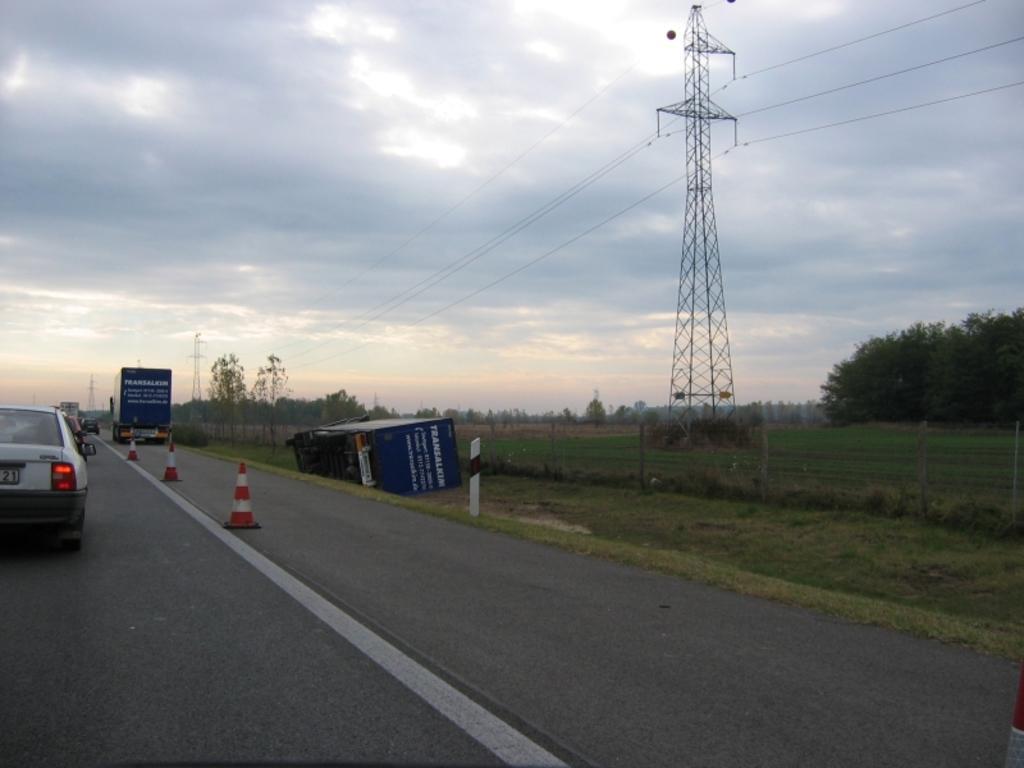In one or two sentences, can you explain what this image depicts? This image is clicked outside. There are trees in the middle. There is sky at the top. There is a tower in the middle. There are cars on the left side. 